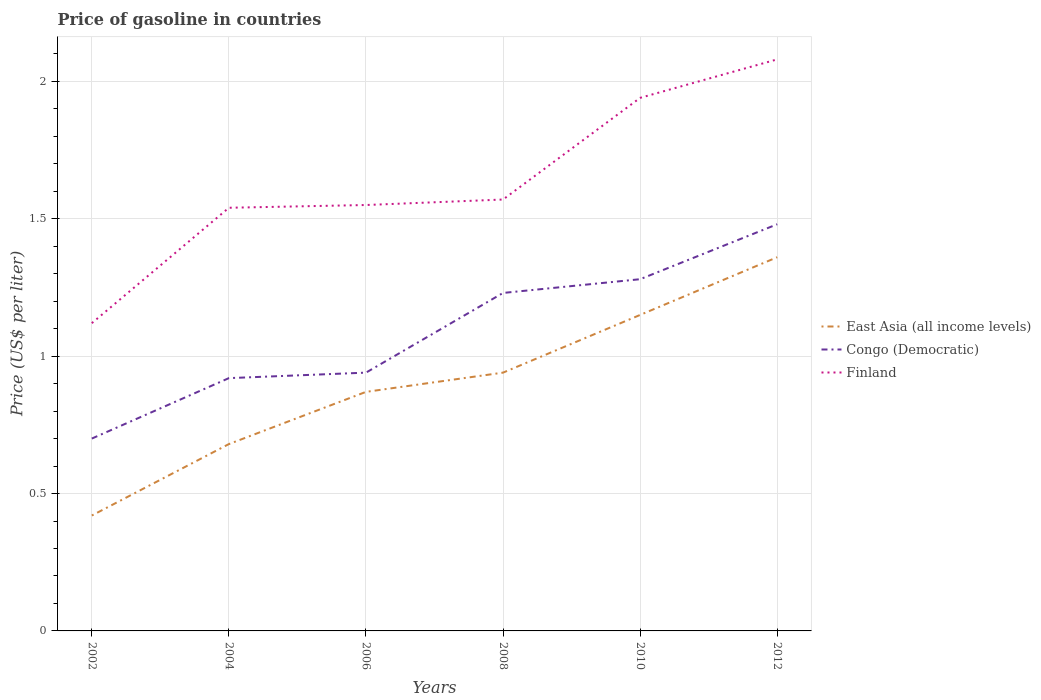How many different coloured lines are there?
Ensure brevity in your answer.  3. Does the line corresponding to Congo (Democratic) intersect with the line corresponding to Finland?
Ensure brevity in your answer.  No. Across all years, what is the maximum price of gasoline in Congo (Democratic)?
Offer a very short reply. 0.7. What is the total price of gasoline in Finland in the graph?
Your answer should be very brief. -0.54. What is the difference between two consecutive major ticks on the Y-axis?
Make the answer very short. 0.5. Does the graph contain any zero values?
Give a very brief answer. No. Does the graph contain grids?
Ensure brevity in your answer.  Yes. How many legend labels are there?
Make the answer very short. 3. What is the title of the graph?
Keep it short and to the point. Price of gasoline in countries. Does "Slovak Republic" appear as one of the legend labels in the graph?
Make the answer very short. No. What is the label or title of the X-axis?
Ensure brevity in your answer.  Years. What is the label or title of the Y-axis?
Your answer should be compact. Price (US$ per liter). What is the Price (US$ per liter) in East Asia (all income levels) in 2002?
Offer a terse response. 0.42. What is the Price (US$ per liter) in Congo (Democratic) in 2002?
Ensure brevity in your answer.  0.7. What is the Price (US$ per liter) of Finland in 2002?
Give a very brief answer. 1.12. What is the Price (US$ per liter) of East Asia (all income levels) in 2004?
Your answer should be compact. 0.68. What is the Price (US$ per liter) of Congo (Democratic) in 2004?
Make the answer very short. 0.92. What is the Price (US$ per liter) in Finland in 2004?
Give a very brief answer. 1.54. What is the Price (US$ per liter) of East Asia (all income levels) in 2006?
Your answer should be compact. 0.87. What is the Price (US$ per liter) in Finland in 2006?
Your answer should be very brief. 1.55. What is the Price (US$ per liter) in Congo (Democratic) in 2008?
Offer a terse response. 1.23. What is the Price (US$ per liter) in Finland in 2008?
Provide a short and direct response. 1.57. What is the Price (US$ per liter) of East Asia (all income levels) in 2010?
Make the answer very short. 1.15. What is the Price (US$ per liter) in Congo (Democratic) in 2010?
Ensure brevity in your answer.  1.28. What is the Price (US$ per liter) in Finland in 2010?
Your response must be concise. 1.94. What is the Price (US$ per liter) of East Asia (all income levels) in 2012?
Your answer should be very brief. 1.36. What is the Price (US$ per liter) of Congo (Democratic) in 2012?
Give a very brief answer. 1.48. What is the Price (US$ per liter) of Finland in 2012?
Make the answer very short. 2.08. Across all years, what is the maximum Price (US$ per liter) of East Asia (all income levels)?
Give a very brief answer. 1.36. Across all years, what is the maximum Price (US$ per liter) of Congo (Democratic)?
Provide a short and direct response. 1.48. Across all years, what is the maximum Price (US$ per liter) in Finland?
Keep it short and to the point. 2.08. Across all years, what is the minimum Price (US$ per liter) in East Asia (all income levels)?
Make the answer very short. 0.42. Across all years, what is the minimum Price (US$ per liter) of Congo (Democratic)?
Your response must be concise. 0.7. Across all years, what is the minimum Price (US$ per liter) in Finland?
Provide a short and direct response. 1.12. What is the total Price (US$ per liter) of East Asia (all income levels) in the graph?
Your answer should be very brief. 5.42. What is the total Price (US$ per liter) of Congo (Democratic) in the graph?
Provide a succinct answer. 6.55. What is the total Price (US$ per liter) in Finland in the graph?
Make the answer very short. 9.8. What is the difference between the Price (US$ per liter) of East Asia (all income levels) in 2002 and that in 2004?
Your answer should be very brief. -0.26. What is the difference between the Price (US$ per liter) of Congo (Democratic) in 2002 and that in 2004?
Your response must be concise. -0.22. What is the difference between the Price (US$ per liter) of Finland in 2002 and that in 2004?
Keep it short and to the point. -0.42. What is the difference between the Price (US$ per liter) in East Asia (all income levels) in 2002 and that in 2006?
Offer a very short reply. -0.45. What is the difference between the Price (US$ per liter) in Congo (Democratic) in 2002 and that in 2006?
Provide a succinct answer. -0.24. What is the difference between the Price (US$ per liter) of Finland in 2002 and that in 2006?
Offer a terse response. -0.43. What is the difference between the Price (US$ per liter) in East Asia (all income levels) in 2002 and that in 2008?
Your answer should be compact. -0.52. What is the difference between the Price (US$ per liter) in Congo (Democratic) in 2002 and that in 2008?
Your answer should be very brief. -0.53. What is the difference between the Price (US$ per liter) in Finland in 2002 and that in 2008?
Provide a succinct answer. -0.45. What is the difference between the Price (US$ per liter) in East Asia (all income levels) in 2002 and that in 2010?
Your answer should be very brief. -0.73. What is the difference between the Price (US$ per liter) in Congo (Democratic) in 2002 and that in 2010?
Offer a terse response. -0.58. What is the difference between the Price (US$ per liter) in Finland in 2002 and that in 2010?
Your response must be concise. -0.82. What is the difference between the Price (US$ per liter) in East Asia (all income levels) in 2002 and that in 2012?
Keep it short and to the point. -0.94. What is the difference between the Price (US$ per liter) of Congo (Democratic) in 2002 and that in 2012?
Ensure brevity in your answer.  -0.78. What is the difference between the Price (US$ per liter) in Finland in 2002 and that in 2012?
Provide a short and direct response. -0.96. What is the difference between the Price (US$ per liter) of East Asia (all income levels) in 2004 and that in 2006?
Provide a succinct answer. -0.19. What is the difference between the Price (US$ per liter) of Congo (Democratic) in 2004 and that in 2006?
Make the answer very short. -0.02. What is the difference between the Price (US$ per liter) of Finland in 2004 and that in 2006?
Make the answer very short. -0.01. What is the difference between the Price (US$ per liter) of East Asia (all income levels) in 2004 and that in 2008?
Give a very brief answer. -0.26. What is the difference between the Price (US$ per liter) in Congo (Democratic) in 2004 and that in 2008?
Make the answer very short. -0.31. What is the difference between the Price (US$ per liter) in Finland in 2004 and that in 2008?
Your answer should be compact. -0.03. What is the difference between the Price (US$ per liter) in East Asia (all income levels) in 2004 and that in 2010?
Ensure brevity in your answer.  -0.47. What is the difference between the Price (US$ per liter) of Congo (Democratic) in 2004 and that in 2010?
Provide a short and direct response. -0.36. What is the difference between the Price (US$ per liter) of Finland in 2004 and that in 2010?
Ensure brevity in your answer.  -0.4. What is the difference between the Price (US$ per liter) of East Asia (all income levels) in 2004 and that in 2012?
Your answer should be compact. -0.68. What is the difference between the Price (US$ per liter) of Congo (Democratic) in 2004 and that in 2012?
Make the answer very short. -0.56. What is the difference between the Price (US$ per liter) of Finland in 2004 and that in 2012?
Keep it short and to the point. -0.54. What is the difference between the Price (US$ per liter) in East Asia (all income levels) in 2006 and that in 2008?
Provide a succinct answer. -0.07. What is the difference between the Price (US$ per liter) of Congo (Democratic) in 2006 and that in 2008?
Offer a very short reply. -0.29. What is the difference between the Price (US$ per liter) in Finland in 2006 and that in 2008?
Make the answer very short. -0.02. What is the difference between the Price (US$ per liter) of East Asia (all income levels) in 2006 and that in 2010?
Give a very brief answer. -0.28. What is the difference between the Price (US$ per liter) of Congo (Democratic) in 2006 and that in 2010?
Your response must be concise. -0.34. What is the difference between the Price (US$ per liter) of Finland in 2006 and that in 2010?
Ensure brevity in your answer.  -0.39. What is the difference between the Price (US$ per liter) in East Asia (all income levels) in 2006 and that in 2012?
Give a very brief answer. -0.49. What is the difference between the Price (US$ per liter) of Congo (Democratic) in 2006 and that in 2012?
Your answer should be very brief. -0.54. What is the difference between the Price (US$ per liter) in Finland in 2006 and that in 2012?
Your answer should be very brief. -0.53. What is the difference between the Price (US$ per liter) in East Asia (all income levels) in 2008 and that in 2010?
Keep it short and to the point. -0.21. What is the difference between the Price (US$ per liter) in Finland in 2008 and that in 2010?
Provide a succinct answer. -0.37. What is the difference between the Price (US$ per liter) in East Asia (all income levels) in 2008 and that in 2012?
Keep it short and to the point. -0.42. What is the difference between the Price (US$ per liter) in Congo (Democratic) in 2008 and that in 2012?
Your answer should be compact. -0.25. What is the difference between the Price (US$ per liter) in Finland in 2008 and that in 2012?
Your answer should be very brief. -0.51. What is the difference between the Price (US$ per liter) in East Asia (all income levels) in 2010 and that in 2012?
Your response must be concise. -0.21. What is the difference between the Price (US$ per liter) of Congo (Democratic) in 2010 and that in 2012?
Offer a very short reply. -0.2. What is the difference between the Price (US$ per liter) of Finland in 2010 and that in 2012?
Make the answer very short. -0.14. What is the difference between the Price (US$ per liter) of East Asia (all income levels) in 2002 and the Price (US$ per liter) of Finland in 2004?
Your answer should be very brief. -1.12. What is the difference between the Price (US$ per liter) of Congo (Democratic) in 2002 and the Price (US$ per liter) of Finland in 2004?
Provide a short and direct response. -0.84. What is the difference between the Price (US$ per liter) of East Asia (all income levels) in 2002 and the Price (US$ per liter) of Congo (Democratic) in 2006?
Make the answer very short. -0.52. What is the difference between the Price (US$ per liter) of East Asia (all income levels) in 2002 and the Price (US$ per liter) of Finland in 2006?
Keep it short and to the point. -1.13. What is the difference between the Price (US$ per liter) of Congo (Democratic) in 2002 and the Price (US$ per liter) of Finland in 2006?
Provide a succinct answer. -0.85. What is the difference between the Price (US$ per liter) in East Asia (all income levels) in 2002 and the Price (US$ per liter) in Congo (Democratic) in 2008?
Your answer should be very brief. -0.81. What is the difference between the Price (US$ per liter) of East Asia (all income levels) in 2002 and the Price (US$ per liter) of Finland in 2008?
Your answer should be very brief. -1.15. What is the difference between the Price (US$ per liter) of Congo (Democratic) in 2002 and the Price (US$ per liter) of Finland in 2008?
Provide a short and direct response. -0.87. What is the difference between the Price (US$ per liter) in East Asia (all income levels) in 2002 and the Price (US$ per liter) in Congo (Democratic) in 2010?
Your response must be concise. -0.86. What is the difference between the Price (US$ per liter) of East Asia (all income levels) in 2002 and the Price (US$ per liter) of Finland in 2010?
Give a very brief answer. -1.52. What is the difference between the Price (US$ per liter) in Congo (Democratic) in 2002 and the Price (US$ per liter) in Finland in 2010?
Give a very brief answer. -1.24. What is the difference between the Price (US$ per liter) in East Asia (all income levels) in 2002 and the Price (US$ per liter) in Congo (Democratic) in 2012?
Provide a short and direct response. -1.06. What is the difference between the Price (US$ per liter) of East Asia (all income levels) in 2002 and the Price (US$ per liter) of Finland in 2012?
Keep it short and to the point. -1.66. What is the difference between the Price (US$ per liter) in Congo (Democratic) in 2002 and the Price (US$ per liter) in Finland in 2012?
Offer a very short reply. -1.38. What is the difference between the Price (US$ per liter) in East Asia (all income levels) in 2004 and the Price (US$ per liter) in Congo (Democratic) in 2006?
Ensure brevity in your answer.  -0.26. What is the difference between the Price (US$ per liter) in East Asia (all income levels) in 2004 and the Price (US$ per liter) in Finland in 2006?
Provide a succinct answer. -0.87. What is the difference between the Price (US$ per liter) in Congo (Democratic) in 2004 and the Price (US$ per liter) in Finland in 2006?
Offer a very short reply. -0.63. What is the difference between the Price (US$ per liter) of East Asia (all income levels) in 2004 and the Price (US$ per liter) of Congo (Democratic) in 2008?
Make the answer very short. -0.55. What is the difference between the Price (US$ per liter) of East Asia (all income levels) in 2004 and the Price (US$ per liter) of Finland in 2008?
Give a very brief answer. -0.89. What is the difference between the Price (US$ per liter) of Congo (Democratic) in 2004 and the Price (US$ per liter) of Finland in 2008?
Provide a short and direct response. -0.65. What is the difference between the Price (US$ per liter) of East Asia (all income levels) in 2004 and the Price (US$ per liter) of Congo (Democratic) in 2010?
Keep it short and to the point. -0.6. What is the difference between the Price (US$ per liter) of East Asia (all income levels) in 2004 and the Price (US$ per liter) of Finland in 2010?
Your response must be concise. -1.26. What is the difference between the Price (US$ per liter) in Congo (Democratic) in 2004 and the Price (US$ per liter) in Finland in 2010?
Provide a succinct answer. -1.02. What is the difference between the Price (US$ per liter) of East Asia (all income levels) in 2004 and the Price (US$ per liter) of Congo (Democratic) in 2012?
Ensure brevity in your answer.  -0.8. What is the difference between the Price (US$ per liter) in East Asia (all income levels) in 2004 and the Price (US$ per liter) in Finland in 2012?
Keep it short and to the point. -1.4. What is the difference between the Price (US$ per liter) in Congo (Democratic) in 2004 and the Price (US$ per liter) in Finland in 2012?
Your answer should be compact. -1.16. What is the difference between the Price (US$ per liter) in East Asia (all income levels) in 2006 and the Price (US$ per liter) in Congo (Democratic) in 2008?
Give a very brief answer. -0.36. What is the difference between the Price (US$ per liter) of East Asia (all income levels) in 2006 and the Price (US$ per liter) of Finland in 2008?
Your response must be concise. -0.7. What is the difference between the Price (US$ per liter) of Congo (Democratic) in 2006 and the Price (US$ per liter) of Finland in 2008?
Your answer should be very brief. -0.63. What is the difference between the Price (US$ per liter) in East Asia (all income levels) in 2006 and the Price (US$ per liter) in Congo (Democratic) in 2010?
Give a very brief answer. -0.41. What is the difference between the Price (US$ per liter) of East Asia (all income levels) in 2006 and the Price (US$ per liter) of Finland in 2010?
Your answer should be compact. -1.07. What is the difference between the Price (US$ per liter) of Congo (Democratic) in 2006 and the Price (US$ per liter) of Finland in 2010?
Your response must be concise. -1. What is the difference between the Price (US$ per liter) of East Asia (all income levels) in 2006 and the Price (US$ per liter) of Congo (Democratic) in 2012?
Provide a short and direct response. -0.61. What is the difference between the Price (US$ per liter) in East Asia (all income levels) in 2006 and the Price (US$ per liter) in Finland in 2012?
Offer a terse response. -1.21. What is the difference between the Price (US$ per liter) of Congo (Democratic) in 2006 and the Price (US$ per liter) of Finland in 2012?
Ensure brevity in your answer.  -1.14. What is the difference between the Price (US$ per liter) of East Asia (all income levels) in 2008 and the Price (US$ per liter) of Congo (Democratic) in 2010?
Offer a terse response. -0.34. What is the difference between the Price (US$ per liter) in Congo (Democratic) in 2008 and the Price (US$ per liter) in Finland in 2010?
Offer a terse response. -0.71. What is the difference between the Price (US$ per liter) of East Asia (all income levels) in 2008 and the Price (US$ per liter) of Congo (Democratic) in 2012?
Make the answer very short. -0.54. What is the difference between the Price (US$ per liter) of East Asia (all income levels) in 2008 and the Price (US$ per liter) of Finland in 2012?
Ensure brevity in your answer.  -1.14. What is the difference between the Price (US$ per liter) in Congo (Democratic) in 2008 and the Price (US$ per liter) in Finland in 2012?
Provide a succinct answer. -0.85. What is the difference between the Price (US$ per liter) in East Asia (all income levels) in 2010 and the Price (US$ per liter) in Congo (Democratic) in 2012?
Your answer should be very brief. -0.33. What is the difference between the Price (US$ per liter) in East Asia (all income levels) in 2010 and the Price (US$ per liter) in Finland in 2012?
Your answer should be very brief. -0.93. What is the difference between the Price (US$ per liter) of Congo (Democratic) in 2010 and the Price (US$ per liter) of Finland in 2012?
Your answer should be very brief. -0.8. What is the average Price (US$ per liter) in East Asia (all income levels) per year?
Provide a short and direct response. 0.9. What is the average Price (US$ per liter) in Congo (Democratic) per year?
Provide a succinct answer. 1.09. What is the average Price (US$ per liter) of Finland per year?
Provide a succinct answer. 1.63. In the year 2002, what is the difference between the Price (US$ per liter) in East Asia (all income levels) and Price (US$ per liter) in Congo (Democratic)?
Keep it short and to the point. -0.28. In the year 2002, what is the difference between the Price (US$ per liter) in East Asia (all income levels) and Price (US$ per liter) in Finland?
Give a very brief answer. -0.7. In the year 2002, what is the difference between the Price (US$ per liter) in Congo (Democratic) and Price (US$ per liter) in Finland?
Give a very brief answer. -0.42. In the year 2004, what is the difference between the Price (US$ per liter) of East Asia (all income levels) and Price (US$ per liter) of Congo (Democratic)?
Offer a terse response. -0.24. In the year 2004, what is the difference between the Price (US$ per liter) in East Asia (all income levels) and Price (US$ per liter) in Finland?
Offer a very short reply. -0.86. In the year 2004, what is the difference between the Price (US$ per liter) in Congo (Democratic) and Price (US$ per liter) in Finland?
Provide a short and direct response. -0.62. In the year 2006, what is the difference between the Price (US$ per liter) of East Asia (all income levels) and Price (US$ per liter) of Congo (Democratic)?
Ensure brevity in your answer.  -0.07. In the year 2006, what is the difference between the Price (US$ per liter) of East Asia (all income levels) and Price (US$ per liter) of Finland?
Offer a terse response. -0.68. In the year 2006, what is the difference between the Price (US$ per liter) of Congo (Democratic) and Price (US$ per liter) of Finland?
Your answer should be very brief. -0.61. In the year 2008, what is the difference between the Price (US$ per liter) of East Asia (all income levels) and Price (US$ per liter) of Congo (Democratic)?
Provide a succinct answer. -0.29. In the year 2008, what is the difference between the Price (US$ per liter) of East Asia (all income levels) and Price (US$ per liter) of Finland?
Provide a succinct answer. -0.63. In the year 2008, what is the difference between the Price (US$ per liter) of Congo (Democratic) and Price (US$ per liter) of Finland?
Provide a succinct answer. -0.34. In the year 2010, what is the difference between the Price (US$ per liter) of East Asia (all income levels) and Price (US$ per liter) of Congo (Democratic)?
Provide a succinct answer. -0.13. In the year 2010, what is the difference between the Price (US$ per liter) of East Asia (all income levels) and Price (US$ per liter) of Finland?
Ensure brevity in your answer.  -0.79. In the year 2010, what is the difference between the Price (US$ per liter) in Congo (Democratic) and Price (US$ per liter) in Finland?
Offer a very short reply. -0.66. In the year 2012, what is the difference between the Price (US$ per liter) of East Asia (all income levels) and Price (US$ per liter) of Congo (Democratic)?
Ensure brevity in your answer.  -0.12. In the year 2012, what is the difference between the Price (US$ per liter) of East Asia (all income levels) and Price (US$ per liter) of Finland?
Your response must be concise. -0.72. What is the ratio of the Price (US$ per liter) in East Asia (all income levels) in 2002 to that in 2004?
Your answer should be compact. 0.62. What is the ratio of the Price (US$ per liter) of Congo (Democratic) in 2002 to that in 2004?
Provide a succinct answer. 0.76. What is the ratio of the Price (US$ per liter) in Finland in 2002 to that in 2004?
Keep it short and to the point. 0.73. What is the ratio of the Price (US$ per liter) in East Asia (all income levels) in 2002 to that in 2006?
Offer a terse response. 0.48. What is the ratio of the Price (US$ per liter) of Congo (Democratic) in 2002 to that in 2006?
Make the answer very short. 0.74. What is the ratio of the Price (US$ per liter) of Finland in 2002 to that in 2006?
Provide a succinct answer. 0.72. What is the ratio of the Price (US$ per liter) of East Asia (all income levels) in 2002 to that in 2008?
Keep it short and to the point. 0.45. What is the ratio of the Price (US$ per liter) of Congo (Democratic) in 2002 to that in 2008?
Your answer should be very brief. 0.57. What is the ratio of the Price (US$ per liter) in Finland in 2002 to that in 2008?
Make the answer very short. 0.71. What is the ratio of the Price (US$ per liter) of East Asia (all income levels) in 2002 to that in 2010?
Ensure brevity in your answer.  0.37. What is the ratio of the Price (US$ per liter) of Congo (Democratic) in 2002 to that in 2010?
Give a very brief answer. 0.55. What is the ratio of the Price (US$ per liter) of Finland in 2002 to that in 2010?
Provide a short and direct response. 0.58. What is the ratio of the Price (US$ per liter) of East Asia (all income levels) in 2002 to that in 2012?
Your response must be concise. 0.31. What is the ratio of the Price (US$ per liter) in Congo (Democratic) in 2002 to that in 2012?
Ensure brevity in your answer.  0.47. What is the ratio of the Price (US$ per liter) in Finland in 2002 to that in 2012?
Offer a very short reply. 0.54. What is the ratio of the Price (US$ per liter) of East Asia (all income levels) in 2004 to that in 2006?
Ensure brevity in your answer.  0.78. What is the ratio of the Price (US$ per liter) in Congo (Democratic) in 2004 to that in 2006?
Make the answer very short. 0.98. What is the ratio of the Price (US$ per liter) in Finland in 2004 to that in 2006?
Give a very brief answer. 0.99. What is the ratio of the Price (US$ per liter) of East Asia (all income levels) in 2004 to that in 2008?
Ensure brevity in your answer.  0.72. What is the ratio of the Price (US$ per liter) in Congo (Democratic) in 2004 to that in 2008?
Your answer should be compact. 0.75. What is the ratio of the Price (US$ per liter) of Finland in 2004 to that in 2008?
Your answer should be compact. 0.98. What is the ratio of the Price (US$ per liter) in East Asia (all income levels) in 2004 to that in 2010?
Provide a short and direct response. 0.59. What is the ratio of the Price (US$ per liter) of Congo (Democratic) in 2004 to that in 2010?
Your answer should be compact. 0.72. What is the ratio of the Price (US$ per liter) in Finland in 2004 to that in 2010?
Provide a succinct answer. 0.79. What is the ratio of the Price (US$ per liter) of East Asia (all income levels) in 2004 to that in 2012?
Your answer should be very brief. 0.5. What is the ratio of the Price (US$ per liter) in Congo (Democratic) in 2004 to that in 2012?
Your response must be concise. 0.62. What is the ratio of the Price (US$ per liter) in Finland in 2004 to that in 2012?
Your answer should be very brief. 0.74. What is the ratio of the Price (US$ per liter) in East Asia (all income levels) in 2006 to that in 2008?
Ensure brevity in your answer.  0.93. What is the ratio of the Price (US$ per liter) of Congo (Democratic) in 2006 to that in 2008?
Your response must be concise. 0.76. What is the ratio of the Price (US$ per liter) of Finland in 2006 to that in 2008?
Make the answer very short. 0.99. What is the ratio of the Price (US$ per liter) in East Asia (all income levels) in 2006 to that in 2010?
Ensure brevity in your answer.  0.76. What is the ratio of the Price (US$ per liter) of Congo (Democratic) in 2006 to that in 2010?
Provide a short and direct response. 0.73. What is the ratio of the Price (US$ per liter) of Finland in 2006 to that in 2010?
Your answer should be compact. 0.8. What is the ratio of the Price (US$ per liter) in East Asia (all income levels) in 2006 to that in 2012?
Your answer should be compact. 0.64. What is the ratio of the Price (US$ per liter) in Congo (Democratic) in 2006 to that in 2012?
Your answer should be compact. 0.64. What is the ratio of the Price (US$ per liter) of Finland in 2006 to that in 2012?
Provide a succinct answer. 0.75. What is the ratio of the Price (US$ per liter) in East Asia (all income levels) in 2008 to that in 2010?
Make the answer very short. 0.82. What is the ratio of the Price (US$ per liter) of Congo (Democratic) in 2008 to that in 2010?
Your answer should be compact. 0.96. What is the ratio of the Price (US$ per liter) of Finland in 2008 to that in 2010?
Offer a very short reply. 0.81. What is the ratio of the Price (US$ per liter) in East Asia (all income levels) in 2008 to that in 2012?
Make the answer very short. 0.69. What is the ratio of the Price (US$ per liter) of Congo (Democratic) in 2008 to that in 2012?
Offer a terse response. 0.83. What is the ratio of the Price (US$ per liter) of Finland in 2008 to that in 2012?
Offer a very short reply. 0.75. What is the ratio of the Price (US$ per liter) of East Asia (all income levels) in 2010 to that in 2012?
Provide a succinct answer. 0.85. What is the ratio of the Price (US$ per liter) in Congo (Democratic) in 2010 to that in 2012?
Your response must be concise. 0.86. What is the ratio of the Price (US$ per liter) of Finland in 2010 to that in 2012?
Your answer should be very brief. 0.93. What is the difference between the highest and the second highest Price (US$ per liter) of East Asia (all income levels)?
Make the answer very short. 0.21. What is the difference between the highest and the second highest Price (US$ per liter) in Finland?
Your answer should be very brief. 0.14. What is the difference between the highest and the lowest Price (US$ per liter) of East Asia (all income levels)?
Provide a short and direct response. 0.94. What is the difference between the highest and the lowest Price (US$ per liter) of Congo (Democratic)?
Your answer should be compact. 0.78. What is the difference between the highest and the lowest Price (US$ per liter) in Finland?
Make the answer very short. 0.96. 